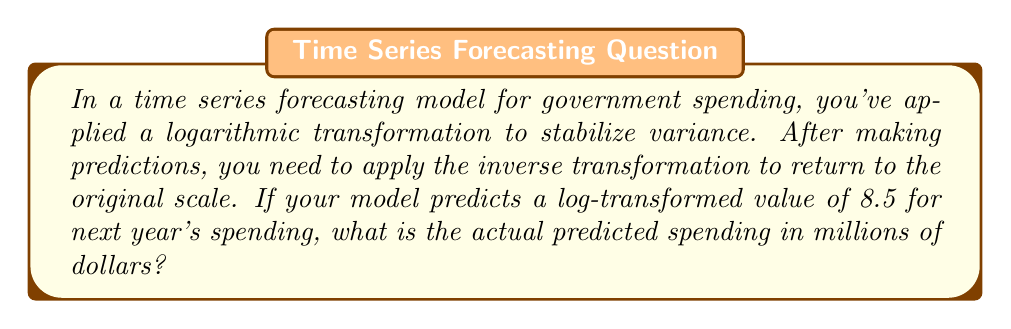Can you answer this question? Let's approach this step-by-step:

1) The original transformation applied was logarithmic, so we used:
   $$y = \log(x)$$
   where $x$ is the original value and $y$ is the transformed value.

2) To get back to the original scale, we need to apply the inverse of the logarithmic function, which is the exponential function:
   $$x = e^y$$

3) In this case, we're given that $y = 8.5$. So we need to calculate:
   $$x = e^{8.5}$$

4) Using a calculator or computer:
   $$e^{8.5} \approx 4914.768$$

5) Since the question asks for the result in millions of dollars, we need to interpret this as 4914.768 million dollars.

6) Rounding to a reasonable number of significant figures for a government budget prediction, we get approximately 4915 million dollars.
Answer: $4915 million 